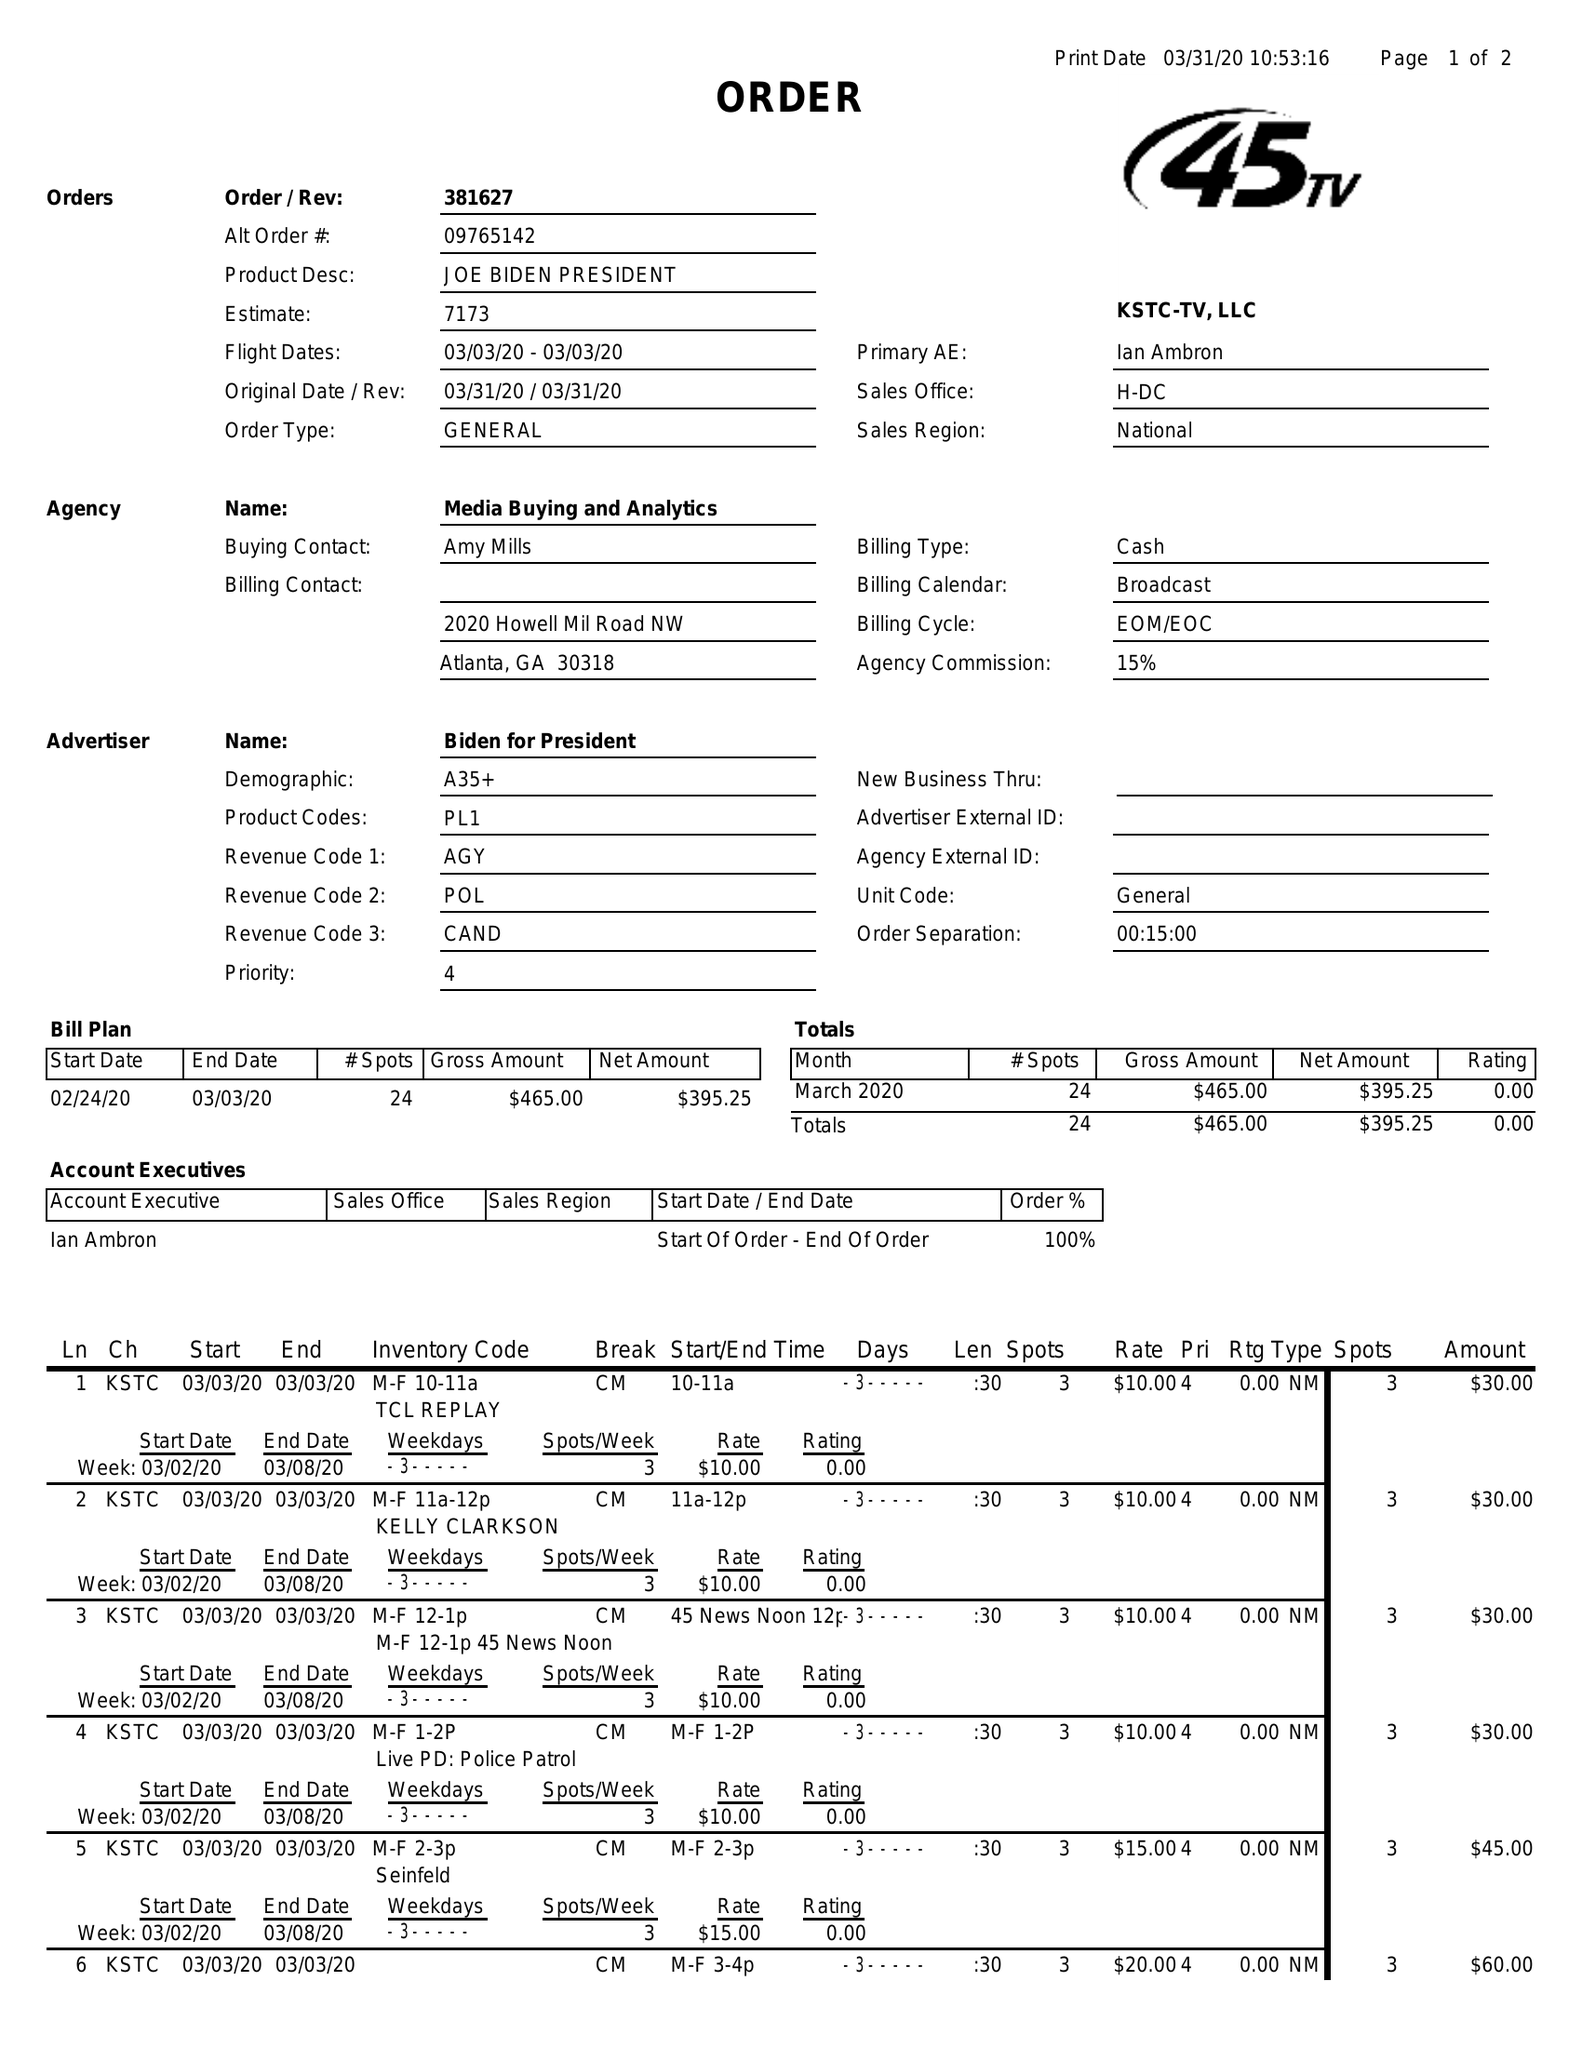What is the value for the contract_num?
Answer the question using a single word or phrase. 381627 